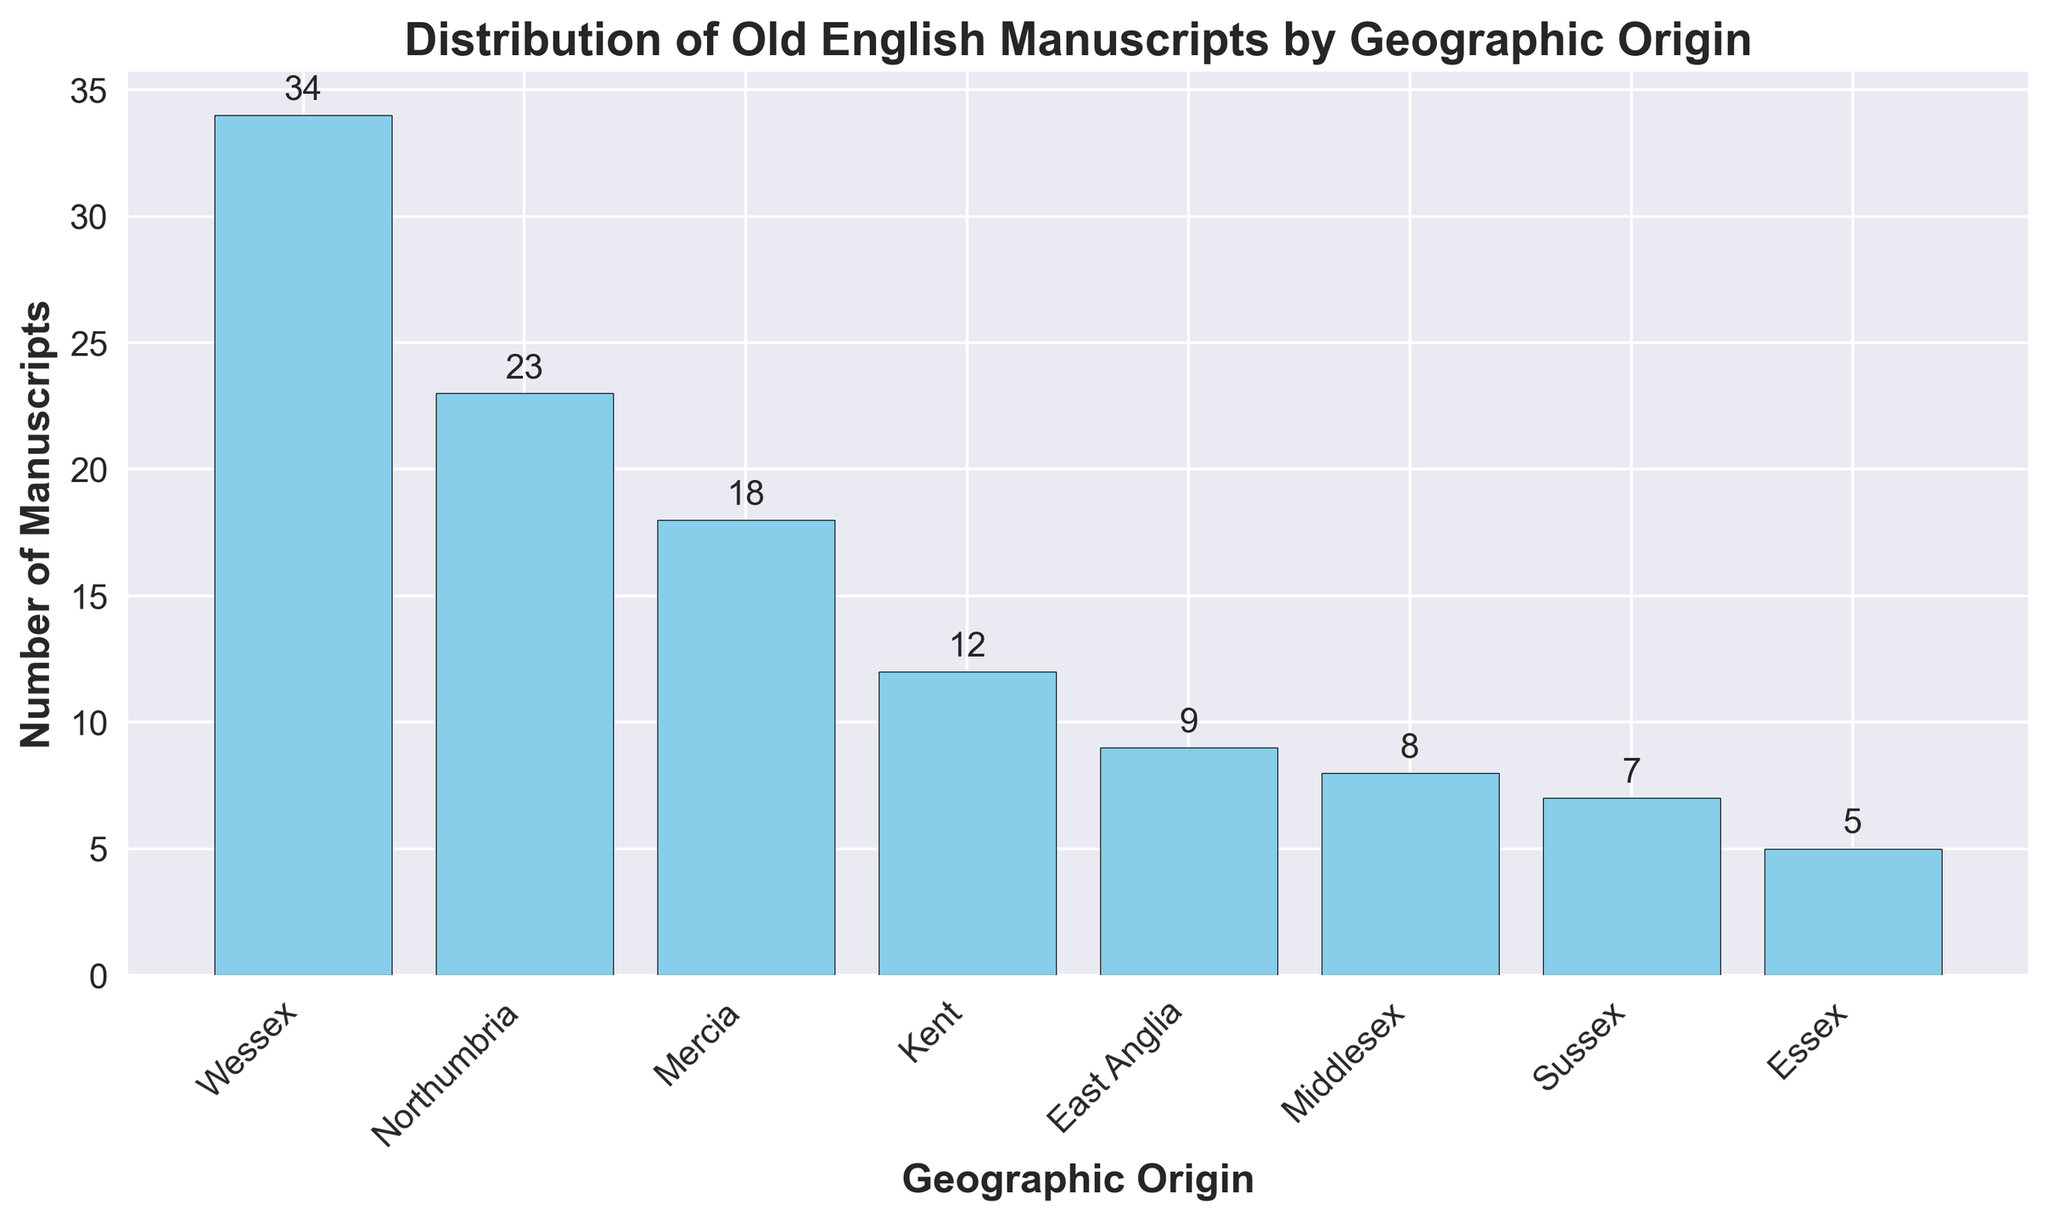What is the total number of Old English manuscripts from Wessex and Northumbria? First, note the number of manuscripts from Wessex (34) and Northumbria (23). Sum the values: 34 + 23 = 57
Answer: 57 Which region has the highest number of Old English manuscripts? Observing the bar chart, the highest bar represents Wessex, which has 34 manuscripts.
Answer: Wessex How many more manuscripts does Mercia have compared to Sussex? Note the number of manuscripts from Mercia (18) and from Sussex (7). Compute the difference: 18 - 7 = 11
Answer: 11 What is the average number of manuscripts across all regions? Sum the total number of manuscripts from all regions (12 + 18 + 23 + 34 + 9 + 5 + 7 + 8 = 116). Divide by the number of regions (8). Thus, the average is 116 / 8 = 14.5
Answer: 14.5 Which regions have fewer than 10 manuscripts? Identify the regions with a bar height indicating fewer than 10 manuscripts: East Anglia (9), Essex (5), Sussex (7), and Middlesex (8)
Answer: East Anglia, Essex, Sussex, Middlesex Are there more manuscripts from Kent and East Anglia combined than from Northumbria alone? Note the number of manuscripts from Kent (12) and East Anglia (9); sum them: 12 + 9 = 21. Northumbria has 23 manuscripts; 21 < 23, so no.
Answer: No Which region has the least number of manuscripts, and how many does it have? Observing the bar chart, the shortest bar represents Essex, which has 5 manuscripts.
Answer: Essex, 5 What is the difference between the number of manuscripts from the region with the most and the region with the least manuscripts? Note the number of manuscripts from Wessex (34) and Essex (5). Compute the difference: 34 - 5 = 29
Answer: 29 How many regions have more than 15 manuscripts? Identify the regions with a bar height indicating more than 15 manuscripts: Mercia (18), Northumbria (23), and Wessex (34), which makes 3 regions.
Answer: 3 What is the combined total of manuscripts from Kent, Essex, and Middlesex? Sum the number of manuscripts from Kent (12), Essex (5), and Middlesex (8): 12 + 5 + 8 = 25
Answer: 25 